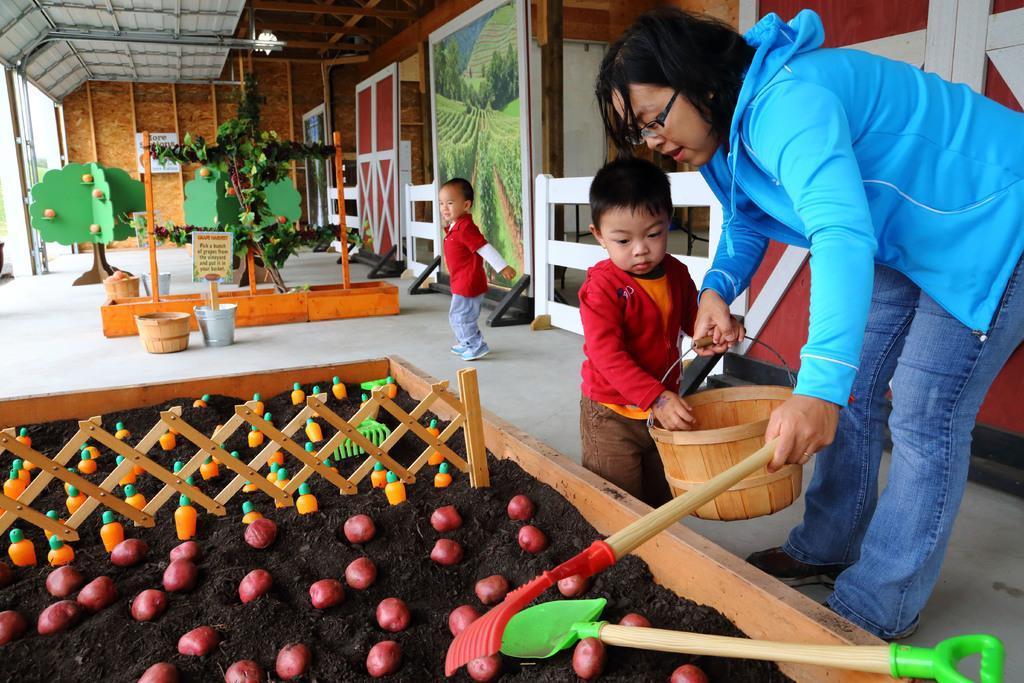Could you give a brief overview of what you see in this image? In this picture we can see a woman is holding a wooden bucket and a shovel and on the left side of the woman there are two kids. In front of the people there are some decorative items and behind the people there is a wooden door and a wall. 